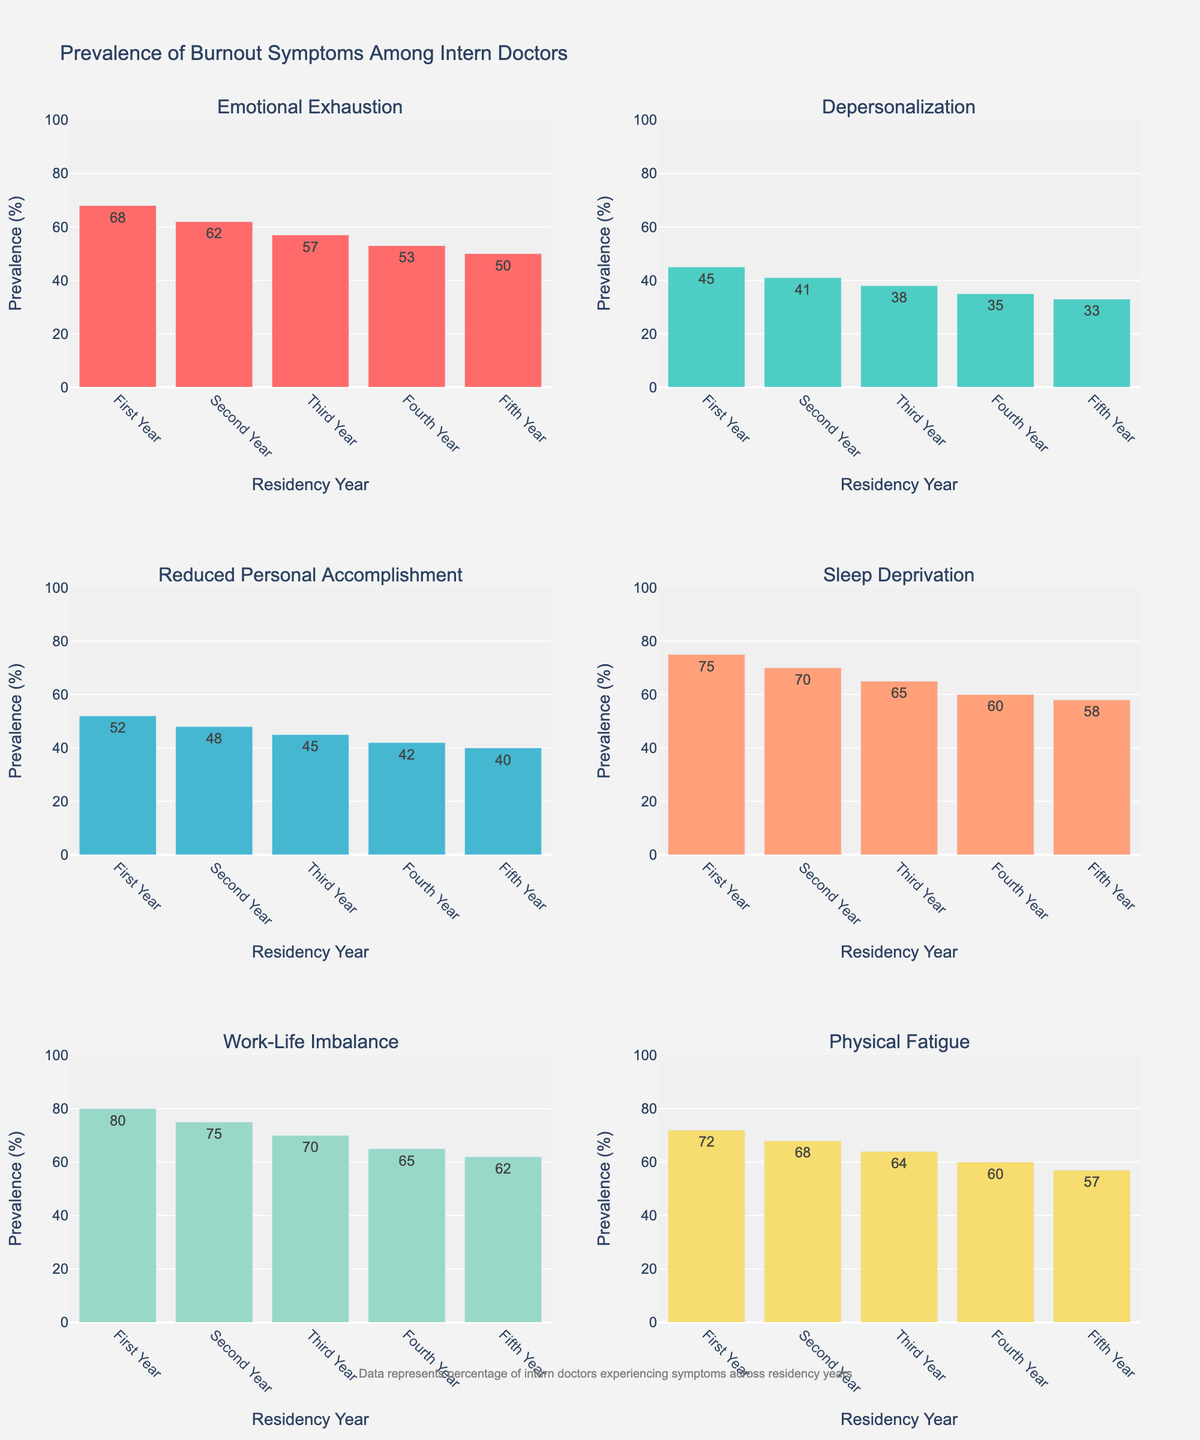What is the title of the scatterplot matrix? The title of the scatterplot matrix is usually displayed prominently at the top of the figure. In this case, it shows "Home Energy Efficiency Analysis".
Answer: Home Energy Efficiency Analysis How many different housing types are displayed in the scatterplot matrix? Different housing types are distinguished by color and symbols in the scatterplot matrix. When counting the distinct markers/legends, we find 20 different housing types.
Answer: 20 Which property has the highest energy efficiency rating, and what type of housing is it? By locating the highest point on the 'Energy Efficiency Rating' axis and identifying its corresponding housing type, we find it's a Condo with a rating of 92.
Answer: Condo What is the relationship between property age and annual utility cost for Single Family Homes? By focusing on the scatter points for 'Single Family Home' and examining their positions along the 'Property Age' and 'Annual Utility Cost' axes, we observe if there's any trend. Typically, older homes tend to have higher utility costs.
Answer: Older homes tend to have higher utility costs Which housing type has the lowest utility costs, and what is its energy efficiency rating? The lowest point on the 'Annual Utility Cost' axis corresponds to the housing type and then correlates that with its Energy Efficiency Rating. The Condo has the lowest utility cost of $950 and an energy efficiency rating of 92.
Answer: Condo, 92 Which housing type had renovations done most recently, and what is its property age? By identifying the latest year on the 'Last Renovation Year' axis and checking the corresponding housing type and property age, we see it's a Condo renovated in 2022 and is 3 years old.
Answer: Condo, 3 years Are there any housing types that have not been renovated since 2000? Check the 'Last Renovation Year' axis for renovations done before 2000 and note their housing types. Victorian (renovated in 1995), Ranch (renovated in 2000), and Farmhouse (renovated in 1999) fall into this category.
Answer: Victorian, Ranch, Farmhouse Compare the average annual utility cost for homes with an energy efficiency rating above 80 and those below 60. Calculate the average utility costs for homes in the two subsets: one with ratings above 80 and another below 60. Above 80 (86, 85, 88, 92) averages around $1056. Below 60 (55, 56, 58, 57, 62) averages around $1905.
Answer: $1056 vs. $1905 Which housing type shows the highest variability in annual utility costs? By observing the spread of data points along the 'Annual Utility Cost' axis for each housing type, the Colonial type shows a wide range from about $1200 to $2000, indicating high variability.
Answer: Colonial Do newer homes tend to have higher energy efficiency ratings than older homes? Assess the scatter plots of 'Property Age' vs. 'Energy Efficiency Rating'. Generally, there is a trend showing newer homes (lower age) cluster at higher efficiency ratings, whereas older homes (higher age) cluster at lower ratings.
Answer: Yes 